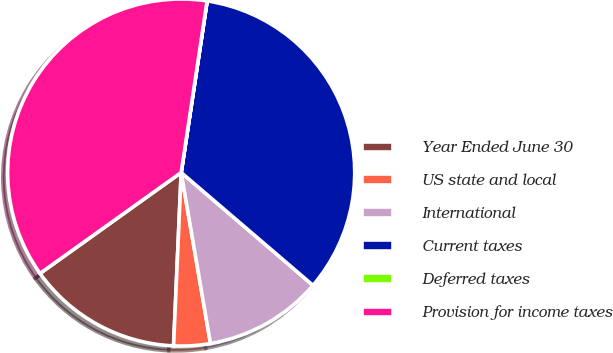<chart> <loc_0><loc_0><loc_500><loc_500><pie_chart><fcel>Year Ended June 30<fcel>US state and local<fcel>International<fcel>Current taxes<fcel>Deferred taxes<fcel>Provision for income taxes<nl><fcel>14.42%<fcel>3.4%<fcel>11.03%<fcel>33.87%<fcel>0.01%<fcel>37.26%<nl></chart> 